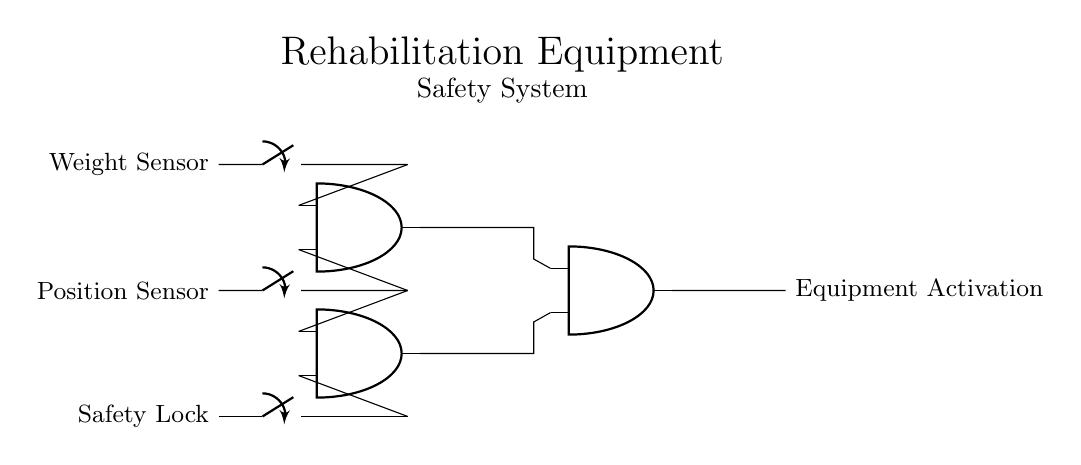What are the inputs for the AND gates? The inputs for the AND gates are the Weight Sensor, Position Sensor, and Safety Lock, as indicated by the connections leading to each of the AND gates.
Answer: Weight Sensor, Position Sensor, Safety Lock How many AND gates are in the circuit? The circuit contains three AND gates, which can be counted as they are represented in the circuit diagram.
Answer: Three What is the output of the circuit? The output of the circuit is Equipment Activation, which is shown as the result from the last AND gate after processing its inputs.
Answer: Equipment Activation What condition must be met for the Equipment Activation to occur? For Equipment Activation to occur, all three inputs (Weight Sensor, Position Sensor, and Safety Lock) must be in the 'ON' position, as required by the nature of AND gates that only output when all inputs are true.
Answer: All inputs ON Which AND gates receive the output from the Weight Sensor? The Weight Sensor directly connects to the first AND gate, which means it is the only AND gate receiving this output.
Answer: First AND gate What happens if one input sensor is off? If one input sensor is off, the corresponding AND gate will not output, leading to no activation of the Equipment Activation in the final output.
Answer: No activation 